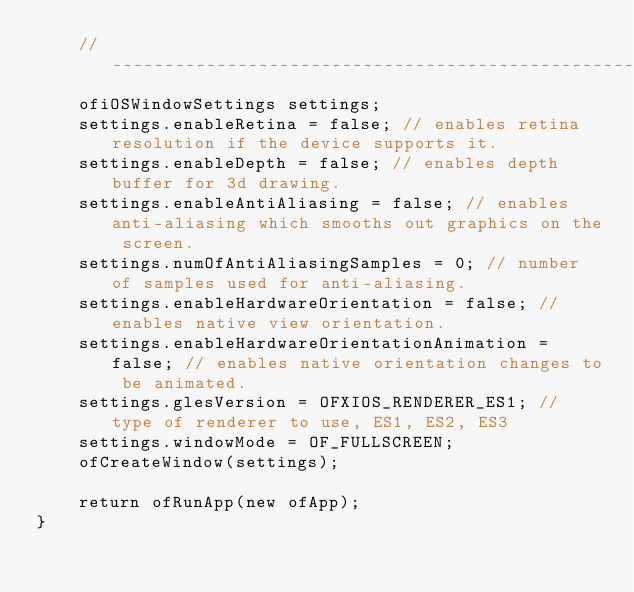<code> <loc_0><loc_0><loc_500><loc_500><_ObjectiveC_>    //------------------------------------------------------
    ofiOSWindowSettings settings;
    settings.enableRetina = false; // enables retina resolution if the device supports it.
    settings.enableDepth = false; // enables depth buffer for 3d drawing.
    settings.enableAntiAliasing = false; // enables anti-aliasing which smooths out graphics on the screen.
    settings.numOfAntiAliasingSamples = 0; // number of samples used for anti-aliasing.
    settings.enableHardwareOrientation = false; // enables native view orientation.
    settings.enableHardwareOrientationAnimation = false; // enables native orientation changes to be animated.
    settings.glesVersion = OFXIOS_RENDERER_ES1; // type of renderer to use, ES1, ES2, ES3
    settings.windowMode = OF_FULLSCREEN;
    ofCreateWindow(settings);
    
    return ofRunApp(new ofApp);
}
</code> 